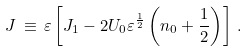Convert formula to latex. <formula><loc_0><loc_0><loc_500><loc_500>J \, \equiv \, \varepsilon \left [ J _ { 1 } - 2 U _ { 0 } \varepsilon ^ { \frac { 1 } { 2 } } \left ( n _ { 0 } + \frac { 1 } { 2 } \right ) \right ] \, .</formula> 